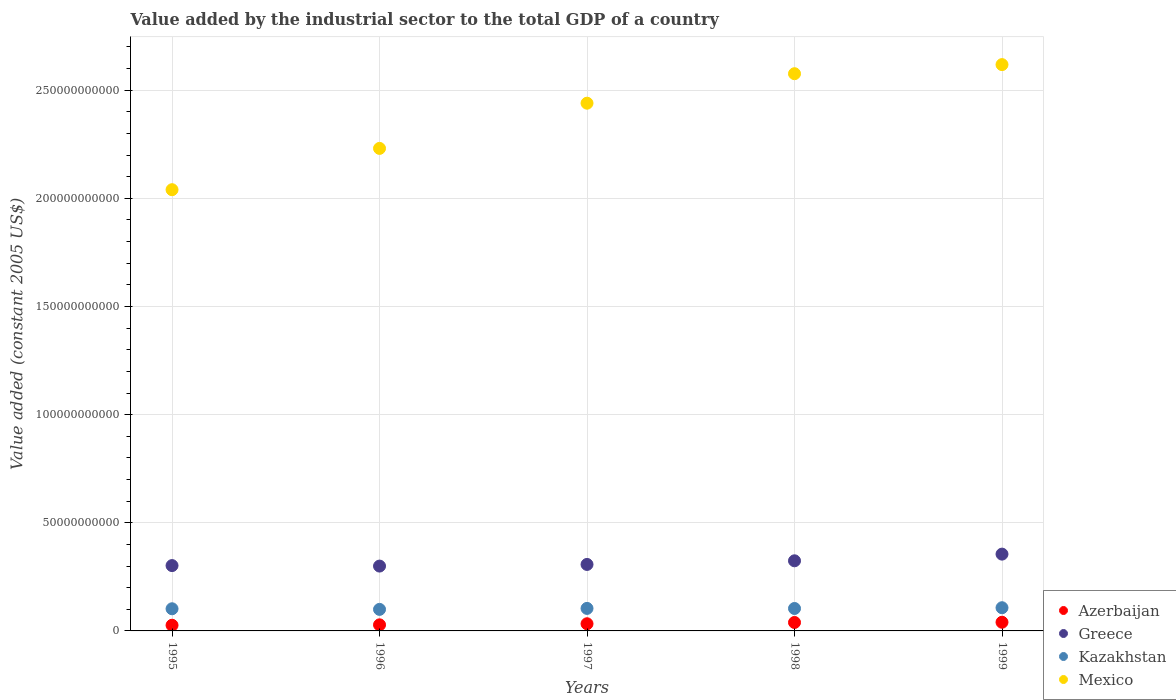How many different coloured dotlines are there?
Provide a succinct answer. 4. What is the value added by the industrial sector in Kazakhstan in 1999?
Your answer should be compact. 1.07e+1. Across all years, what is the maximum value added by the industrial sector in Mexico?
Give a very brief answer. 2.62e+11. Across all years, what is the minimum value added by the industrial sector in Kazakhstan?
Keep it short and to the point. 9.96e+09. In which year was the value added by the industrial sector in Mexico minimum?
Your answer should be compact. 1995. What is the total value added by the industrial sector in Mexico in the graph?
Your answer should be compact. 1.19e+12. What is the difference between the value added by the industrial sector in Greece in 1995 and that in 1999?
Provide a succinct answer. -5.30e+09. What is the difference between the value added by the industrial sector in Kazakhstan in 1999 and the value added by the industrial sector in Mexico in 1996?
Offer a very short reply. -2.12e+11. What is the average value added by the industrial sector in Mexico per year?
Ensure brevity in your answer.  2.38e+11. In the year 1995, what is the difference between the value added by the industrial sector in Kazakhstan and value added by the industrial sector in Azerbaijan?
Provide a succinct answer. 7.62e+09. In how many years, is the value added by the industrial sector in Azerbaijan greater than 80000000000 US$?
Give a very brief answer. 0. What is the ratio of the value added by the industrial sector in Azerbaijan in 1998 to that in 1999?
Your response must be concise. 0.97. What is the difference between the highest and the second highest value added by the industrial sector in Mexico?
Make the answer very short. 4.21e+09. What is the difference between the highest and the lowest value added by the industrial sector in Kazakhstan?
Your answer should be very brief. 7.63e+08. Is the sum of the value added by the industrial sector in Mexico in 1997 and 1999 greater than the maximum value added by the industrial sector in Kazakhstan across all years?
Offer a very short reply. Yes. Is it the case that in every year, the sum of the value added by the industrial sector in Kazakhstan and value added by the industrial sector in Azerbaijan  is greater than the sum of value added by the industrial sector in Mexico and value added by the industrial sector in Greece?
Your response must be concise. Yes. Is it the case that in every year, the sum of the value added by the industrial sector in Greece and value added by the industrial sector in Mexico  is greater than the value added by the industrial sector in Azerbaijan?
Keep it short and to the point. Yes. How many years are there in the graph?
Your answer should be very brief. 5. What is the difference between two consecutive major ticks on the Y-axis?
Offer a terse response. 5.00e+1. Does the graph contain grids?
Give a very brief answer. Yes. Where does the legend appear in the graph?
Offer a very short reply. Bottom right. How are the legend labels stacked?
Offer a terse response. Vertical. What is the title of the graph?
Provide a succinct answer. Value added by the industrial sector to the total GDP of a country. What is the label or title of the X-axis?
Your answer should be compact. Years. What is the label or title of the Y-axis?
Your answer should be very brief. Value added (constant 2005 US$). What is the Value added (constant 2005 US$) in Azerbaijan in 1995?
Ensure brevity in your answer.  2.62e+09. What is the Value added (constant 2005 US$) in Greece in 1995?
Your response must be concise. 3.02e+1. What is the Value added (constant 2005 US$) of Kazakhstan in 1995?
Your answer should be compact. 1.02e+1. What is the Value added (constant 2005 US$) of Mexico in 1995?
Give a very brief answer. 2.04e+11. What is the Value added (constant 2005 US$) of Azerbaijan in 1996?
Offer a terse response. 2.81e+09. What is the Value added (constant 2005 US$) of Greece in 1996?
Your response must be concise. 3.00e+1. What is the Value added (constant 2005 US$) of Kazakhstan in 1996?
Make the answer very short. 9.96e+09. What is the Value added (constant 2005 US$) in Mexico in 1996?
Provide a short and direct response. 2.23e+11. What is the Value added (constant 2005 US$) in Azerbaijan in 1997?
Provide a succinct answer. 3.31e+09. What is the Value added (constant 2005 US$) of Greece in 1997?
Give a very brief answer. 3.07e+1. What is the Value added (constant 2005 US$) in Kazakhstan in 1997?
Your answer should be very brief. 1.04e+1. What is the Value added (constant 2005 US$) in Mexico in 1997?
Your response must be concise. 2.44e+11. What is the Value added (constant 2005 US$) of Azerbaijan in 1998?
Your answer should be compact. 3.91e+09. What is the Value added (constant 2005 US$) in Greece in 1998?
Your answer should be compact. 3.24e+1. What is the Value added (constant 2005 US$) of Kazakhstan in 1998?
Provide a short and direct response. 1.04e+1. What is the Value added (constant 2005 US$) of Mexico in 1998?
Provide a short and direct response. 2.58e+11. What is the Value added (constant 2005 US$) of Azerbaijan in 1999?
Give a very brief answer. 4.01e+09. What is the Value added (constant 2005 US$) of Greece in 1999?
Give a very brief answer. 3.55e+1. What is the Value added (constant 2005 US$) of Kazakhstan in 1999?
Make the answer very short. 1.07e+1. What is the Value added (constant 2005 US$) in Mexico in 1999?
Provide a short and direct response. 2.62e+11. Across all years, what is the maximum Value added (constant 2005 US$) in Azerbaijan?
Offer a very short reply. 4.01e+09. Across all years, what is the maximum Value added (constant 2005 US$) of Greece?
Make the answer very short. 3.55e+1. Across all years, what is the maximum Value added (constant 2005 US$) in Kazakhstan?
Your answer should be compact. 1.07e+1. Across all years, what is the maximum Value added (constant 2005 US$) of Mexico?
Your response must be concise. 2.62e+11. Across all years, what is the minimum Value added (constant 2005 US$) of Azerbaijan?
Offer a terse response. 2.62e+09. Across all years, what is the minimum Value added (constant 2005 US$) of Greece?
Your answer should be very brief. 3.00e+1. Across all years, what is the minimum Value added (constant 2005 US$) of Kazakhstan?
Provide a succinct answer. 9.96e+09. Across all years, what is the minimum Value added (constant 2005 US$) of Mexico?
Offer a terse response. 2.04e+11. What is the total Value added (constant 2005 US$) in Azerbaijan in the graph?
Give a very brief answer. 1.67e+1. What is the total Value added (constant 2005 US$) of Greece in the graph?
Give a very brief answer. 1.59e+11. What is the total Value added (constant 2005 US$) in Kazakhstan in the graph?
Your answer should be compact. 5.17e+1. What is the total Value added (constant 2005 US$) of Mexico in the graph?
Your response must be concise. 1.19e+12. What is the difference between the Value added (constant 2005 US$) of Azerbaijan in 1995 and that in 1996?
Keep it short and to the point. -1.91e+08. What is the difference between the Value added (constant 2005 US$) of Greece in 1995 and that in 1996?
Your answer should be very brief. 2.27e+08. What is the difference between the Value added (constant 2005 US$) in Kazakhstan in 1995 and that in 1996?
Offer a terse response. 2.82e+08. What is the difference between the Value added (constant 2005 US$) of Mexico in 1995 and that in 1996?
Ensure brevity in your answer.  -1.91e+1. What is the difference between the Value added (constant 2005 US$) of Azerbaijan in 1995 and that in 1997?
Provide a succinct answer. -6.90e+08. What is the difference between the Value added (constant 2005 US$) of Greece in 1995 and that in 1997?
Give a very brief answer. -5.31e+08. What is the difference between the Value added (constant 2005 US$) in Kazakhstan in 1995 and that in 1997?
Your response must be concise. -1.69e+08. What is the difference between the Value added (constant 2005 US$) of Mexico in 1995 and that in 1997?
Your answer should be very brief. -4.00e+1. What is the difference between the Value added (constant 2005 US$) of Azerbaijan in 1995 and that in 1998?
Offer a very short reply. -1.28e+09. What is the difference between the Value added (constant 2005 US$) in Greece in 1995 and that in 1998?
Provide a succinct answer. -2.22e+09. What is the difference between the Value added (constant 2005 US$) of Kazakhstan in 1995 and that in 1998?
Provide a short and direct response. -1.28e+08. What is the difference between the Value added (constant 2005 US$) of Mexico in 1995 and that in 1998?
Provide a succinct answer. -5.36e+1. What is the difference between the Value added (constant 2005 US$) of Azerbaijan in 1995 and that in 1999?
Your answer should be compact. -1.39e+09. What is the difference between the Value added (constant 2005 US$) of Greece in 1995 and that in 1999?
Your response must be concise. -5.30e+09. What is the difference between the Value added (constant 2005 US$) of Kazakhstan in 1995 and that in 1999?
Offer a terse response. -4.80e+08. What is the difference between the Value added (constant 2005 US$) of Mexico in 1995 and that in 1999?
Provide a short and direct response. -5.78e+1. What is the difference between the Value added (constant 2005 US$) in Azerbaijan in 1996 and that in 1997?
Provide a short and direct response. -4.99e+08. What is the difference between the Value added (constant 2005 US$) in Greece in 1996 and that in 1997?
Ensure brevity in your answer.  -7.58e+08. What is the difference between the Value added (constant 2005 US$) in Kazakhstan in 1996 and that in 1997?
Ensure brevity in your answer.  -4.52e+08. What is the difference between the Value added (constant 2005 US$) in Mexico in 1996 and that in 1997?
Keep it short and to the point. -2.09e+1. What is the difference between the Value added (constant 2005 US$) of Azerbaijan in 1996 and that in 1998?
Make the answer very short. -1.09e+09. What is the difference between the Value added (constant 2005 US$) of Greece in 1996 and that in 1998?
Offer a terse response. -2.44e+09. What is the difference between the Value added (constant 2005 US$) in Kazakhstan in 1996 and that in 1998?
Provide a succinct answer. -4.10e+08. What is the difference between the Value added (constant 2005 US$) in Mexico in 1996 and that in 1998?
Provide a succinct answer. -3.45e+1. What is the difference between the Value added (constant 2005 US$) of Azerbaijan in 1996 and that in 1999?
Ensure brevity in your answer.  -1.19e+09. What is the difference between the Value added (constant 2005 US$) in Greece in 1996 and that in 1999?
Your response must be concise. -5.53e+09. What is the difference between the Value added (constant 2005 US$) of Kazakhstan in 1996 and that in 1999?
Offer a terse response. -7.63e+08. What is the difference between the Value added (constant 2005 US$) of Mexico in 1996 and that in 1999?
Give a very brief answer. -3.87e+1. What is the difference between the Value added (constant 2005 US$) of Azerbaijan in 1997 and that in 1998?
Keep it short and to the point. -5.93e+08. What is the difference between the Value added (constant 2005 US$) in Greece in 1997 and that in 1998?
Ensure brevity in your answer.  -1.68e+09. What is the difference between the Value added (constant 2005 US$) in Kazakhstan in 1997 and that in 1998?
Give a very brief answer. 4.17e+07. What is the difference between the Value added (constant 2005 US$) in Mexico in 1997 and that in 1998?
Offer a very short reply. -1.36e+1. What is the difference between the Value added (constant 2005 US$) in Azerbaijan in 1997 and that in 1999?
Provide a succinct answer. -6.96e+08. What is the difference between the Value added (constant 2005 US$) of Greece in 1997 and that in 1999?
Give a very brief answer. -4.77e+09. What is the difference between the Value added (constant 2005 US$) of Kazakhstan in 1997 and that in 1999?
Your answer should be very brief. -3.11e+08. What is the difference between the Value added (constant 2005 US$) of Mexico in 1997 and that in 1999?
Your answer should be compact. -1.78e+1. What is the difference between the Value added (constant 2005 US$) of Azerbaijan in 1998 and that in 1999?
Make the answer very short. -1.03e+08. What is the difference between the Value added (constant 2005 US$) in Greece in 1998 and that in 1999?
Keep it short and to the point. -3.09e+09. What is the difference between the Value added (constant 2005 US$) of Kazakhstan in 1998 and that in 1999?
Your answer should be very brief. -3.53e+08. What is the difference between the Value added (constant 2005 US$) of Mexico in 1998 and that in 1999?
Give a very brief answer. -4.21e+09. What is the difference between the Value added (constant 2005 US$) in Azerbaijan in 1995 and the Value added (constant 2005 US$) in Greece in 1996?
Keep it short and to the point. -2.74e+1. What is the difference between the Value added (constant 2005 US$) of Azerbaijan in 1995 and the Value added (constant 2005 US$) of Kazakhstan in 1996?
Offer a terse response. -7.34e+09. What is the difference between the Value added (constant 2005 US$) of Azerbaijan in 1995 and the Value added (constant 2005 US$) of Mexico in 1996?
Offer a very short reply. -2.20e+11. What is the difference between the Value added (constant 2005 US$) of Greece in 1995 and the Value added (constant 2005 US$) of Kazakhstan in 1996?
Keep it short and to the point. 2.02e+1. What is the difference between the Value added (constant 2005 US$) of Greece in 1995 and the Value added (constant 2005 US$) of Mexico in 1996?
Offer a terse response. -1.93e+11. What is the difference between the Value added (constant 2005 US$) in Kazakhstan in 1995 and the Value added (constant 2005 US$) in Mexico in 1996?
Keep it short and to the point. -2.13e+11. What is the difference between the Value added (constant 2005 US$) of Azerbaijan in 1995 and the Value added (constant 2005 US$) of Greece in 1997?
Your answer should be very brief. -2.81e+1. What is the difference between the Value added (constant 2005 US$) of Azerbaijan in 1995 and the Value added (constant 2005 US$) of Kazakhstan in 1997?
Make the answer very short. -7.79e+09. What is the difference between the Value added (constant 2005 US$) in Azerbaijan in 1995 and the Value added (constant 2005 US$) in Mexico in 1997?
Your answer should be compact. -2.41e+11. What is the difference between the Value added (constant 2005 US$) of Greece in 1995 and the Value added (constant 2005 US$) of Kazakhstan in 1997?
Your answer should be compact. 1.98e+1. What is the difference between the Value added (constant 2005 US$) in Greece in 1995 and the Value added (constant 2005 US$) in Mexico in 1997?
Keep it short and to the point. -2.14e+11. What is the difference between the Value added (constant 2005 US$) of Kazakhstan in 1995 and the Value added (constant 2005 US$) of Mexico in 1997?
Your answer should be very brief. -2.34e+11. What is the difference between the Value added (constant 2005 US$) in Azerbaijan in 1995 and the Value added (constant 2005 US$) in Greece in 1998?
Your response must be concise. -2.98e+1. What is the difference between the Value added (constant 2005 US$) of Azerbaijan in 1995 and the Value added (constant 2005 US$) of Kazakhstan in 1998?
Provide a succinct answer. -7.75e+09. What is the difference between the Value added (constant 2005 US$) in Azerbaijan in 1995 and the Value added (constant 2005 US$) in Mexico in 1998?
Offer a very short reply. -2.55e+11. What is the difference between the Value added (constant 2005 US$) of Greece in 1995 and the Value added (constant 2005 US$) of Kazakhstan in 1998?
Ensure brevity in your answer.  1.98e+1. What is the difference between the Value added (constant 2005 US$) in Greece in 1995 and the Value added (constant 2005 US$) in Mexico in 1998?
Provide a succinct answer. -2.27e+11. What is the difference between the Value added (constant 2005 US$) in Kazakhstan in 1995 and the Value added (constant 2005 US$) in Mexico in 1998?
Your answer should be compact. -2.47e+11. What is the difference between the Value added (constant 2005 US$) of Azerbaijan in 1995 and the Value added (constant 2005 US$) of Greece in 1999?
Offer a terse response. -3.29e+1. What is the difference between the Value added (constant 2005 US$) of Azerbaijan in 1995 and the Value added (constant 2005 US$) of Kazakhstan in 1999?
Ensure brevity in your answer.  -8.10e+09. What is the difference between the Value added (constant 2005 US$) in Azerbaijan in 1995 and the Value added (constant 2005 US$) in Mexico in 1999?
Make the answer very short. -2.59e+11. What is the difference between the Value added (constant 2005 US$) in Greece in 1995 and the Value added (constant 2005 US$) in Kazakhstan in 1999?
Your response must be concise. 1.95e+1. What is the difference between the Value added (constant 2005 US$) of Greece in 1995 and the Value added (constant 2005 US$) of Mexico in 1999?
Your response must be concise. -2.32e+11. What is the difference between the Value added (constant 2005 US$) of Kazakhstan in 1995 and the Value added (constant 2005 US$) of Mexico in 1999?
Provide a succinct answer. -2.52e+11. What is the difference between the Value added (constant 2005 US$) in Azerbaijan in 1996 and the Value added (constant 2005 US$) in Greece in 1997?
Your answer should be very brief. -2.79e+1. What is the difference between the Value added (constant 2005 US$) of Azerbaijan in 1996 and the Value added (constant 2005 US$) of Kazakhstan in 1997?
Provide a short and direct response. -7.60e+09. What is the difference between the Value added (constant 2005 US$) in Azerbaijan in 1996 and the Value added (constant 2005 US$) in Mexico in 1997?
Your answer should be very brief. -2.41e+11. What is the difference between the Value added (constant 2005 US$) in Greece in 1996 and the Value added (constant 2005 US$) in Kazakhstan in 1997?
Provide a short and direct response. 1.96e+1. What is the difference between the Value added (constant 2005 US$) of Greece in 1996 and the Value added (constant 2005 US$) of Mexico in 1997?
Offer a very short reply. -2.14e+11. What is the difference between the Value added (constant 2005 US$) in Kazakhstan in 1996 and the Value added (constant 2005 US$) in Mexico in 1997?
Make the answer very short. -2.34e+11. What is the difference between the Value added (constant 2005 US$) in Azerbaijan in 1996 and the Value added (constant 2005 US$) in Greece in 1998?
Your answer should be compact. -2.96e+1. What is the difference between the Value added (constant 2005 US$) in Azerbaijan in 1996 and the Value added (constant 2005 US$) in Kazakhstan in 1998?
Your answer should be compact. -7.56e+09. What is the difference between the Value added (constant 2005 US$) of Azerbaijan in 1996 and the Value added (constant 2005 US$) of Mexico in 1998?
Keep it short and to the point. -2.55e+11. What is the difference between the Value added (constant 2005 US$) of Greece in 1996 and the Value added (constant 2005 US$) of Kazakhstan in 1998?
Your answer should be very brief. 1.96e+1. What is the difference between the Value added (constant 2005 US$) in Greece in 1996 and the Value added (constant 2005 US$) in Mexico in 1998?
Provide a succinct answer. -2.28e+11. What is the difference between the Value added (constant 2005 US$) of Kazakhstan in 1996 and the Value added (constant 2005 US$) of Mexico in 1998?
Make the answer very short. -2.48e+11. What is the difference between the Value added (constant 2005 US$) in Azerbaijan in 1996 and the Value added (constant 2005 US$) in Greece in 1999?
Provide a succinct answer. -3.27e+1. What is the difference between the Value added (constant 2005 US$) of Azerbaijan in 1996 and the Value added (constant 2005 US$) of Kazakhstan in 1999?
Keep it short and to the point. -7.91e+09. What is the difference between the Value added (constant 2005 US$) of Azerbaijan in 1996 and the Value added (constant 2005 US$) of Mexico in 1999?
Give a very brief answer. -2.59e+11. What is the difference between the Value added (constant 2005 US$) in Greece in 1996 and the Value added (constant 2005 US$) in Kazakhstan in 1999?
Give a very brief answer. 1.93e+1. What is the difference between the Value added (constant 2005 US$) of Greece in 1996 and the Value added (constant 2005 US$) of Mexico in 1999?
Ensure brevity in your answer.  -2.32e+11. What is the difference between the Value added (constant 2005 US$) of Kazakhstan in 1996 and the Value added (constant 2005 US$) of Mexico in 1999?
Your response must be concise. -2.52e+11. What is the difference between the Value added (constant 2005 US$) of Azerbaijan in 1997 and the Value added (constant 2005 US$) of Greece in 1998?
Provide a short and direct response. -2.91e+1. What is the difference between the Value added (constant 2005 US$) of Azerbaijan in 1997 and the Value added (constant 2005 US$) of Kazakhstan in 1998?
Offer a terse response. -7.06e+09. What is the difference between the Value added (constant 2005 US$) of Azerbaijan in 1997 and the Value added (constant 2005 US$) of Mexico in 1998?
Your response must be concise. -2.54e+11. What is the difference between the Value added (constant 2005 US$) of Greece in 1997 and the Value added (constant 2005 US$) of Kazakhstan in 1998?
Offer a very short reply. 2.04e+1. What is the difference between the Value added (constant 2005 US$) in Greece in 1997 and the Value added (constant 2005 US$) in Mexico in 1998?
Your answer should be compact. -2.27e+11. What is the difference between the Value added (constant 2005 US$) in Kazakhstan in 1997 and the Value added (constant 2005 US$) in Mexico in 1998?
Make the answer very short. -2.47e+11. What is the difference between the Value added (constant 2005 US$) of Azerbaijan in 1997 and the Value added (constant 2005 US$) of Greece in 1999?
Your response must be concise. -3.22e+1. What is the difference between the Value added (constant 2005 US$) in Azerbaijan in 1997 and the Value added (constant 2005 US$) in Kazakhstan in 1999?
Ensure brevity in your answer.  -7.41e+09. What is the difference between the Value added (constant 2005 US$) of Azerbaijan in 1997 and the Value added (constant 2005 US$) of Mexico in 1999?
Your answer should be compact. -2.59e+11. What is the difference between the Value added (constant 2005 US$) of Greece in 1997 and the Value added (constant 2005 US$) of Kazakhstan in 1999?
Keep it short and to the point. 2.00e+1. What is the difference between the Value added (constant 2005 US$) of Greece in 1997 and the Value added (constant 2005 US$) of Mexico in 1999?
Make the answer very short. -2.31e+11. What is the difference between the Value added (constant 2005 US$) in Kazakhstan in 1997 and the Value added (constant 2005 US$) in Mexico in 1999?
Provide a succinct answer. -2.51e+11. What is the difference between the Value added (constant 2005 US$) of Azerbaijan in 1998 and the Value added (constant 2005 US$) of Greece in 1999?
Provide a short and direct response. -3.16e+1. What is the difference between the Value added (constant 2005 US$) of Azerbaijan in 1998 and the Value added (constant 2005 US$) of Kazakhstan in 1999?
Ensure brevity in your answer.  -6.82e+09. What is the difference between the Value added (constant 2005 US$) in Azerbaijan in 1998 and the Value added (constant 2005 US$) in Mexico in 1999?
Make the answer very short. -2.58e+11. What is the difference between the Value added (constant 2005 US$) of Greece in 1998 and the Value added (constant 2005 US$) of Kazakhstan in 1999?
Give a very brief answer. 2.17e+1. What is the difference between the Value added (constant 2005 US$) in Greece in 1998 and the Value added (constant 2005 US$) in Mexico in 1999?
Your answer should be very brief. -2.29e+11. What is the difference between the Value added (constant 2005 US$) of Kazakhstan in 1998 and the Value added (constant 2005 US$) of Mexico in 1999?
Your answer should be very brief. -2.51e+11. What is the average Value added (constant 2005 US$) of Azerbaijan per year?
Keep it short and to the point. 3.33e+09. What is the average Value added (constant 2005 US$) of Greece per year?
Your answer should be compact. 3.18e+1. What is the average Value added (constant 2005 US$) in Kazakhstan per year?
Make the answer very short. 1.03e+1. What is the average Value added (constant 2005 US$) of Mexico per year?
Your answer should be compact. 2.38e+11. In the year 1995, what is the difference between the Value added (constant 2005 US$) in Azerbaijan and Value added (constant 2005 US$) in Greece?
Provide a short and direct response. -2.76e+1. In the year 1995, what is the difference between the Value added (constant 2005 US$) of Azerbaijan and Value added (constant 2005 US$) of Kazakhstan?
Provide a succinct answer. -7.62e+09. In the year 1995, what is the difference between the Value added (constant 2005 US$) of Azerbaijan and Value added (constant 2005 US$) of Mexico?
Provide a succinct answer. -2.01e+11. In the year 1995, what is the difference between the Value added (constant 2005 US$) in Greece and Value added (constant 2005 US$) in Kazakhstan?
Provide a succinct answer. 2.00e+1. In the year 1995, what is the difference between the Value added (constant 2005 US$) of Greece and Value added (constant 2005 US$) of Mexico?
Your answer should be compact. -1.74e+11. In the year 1995, what is the difference between the Value added (constant 2005 US$) in Kazakhstan and Value added (constant 2005 US$) in Mexico?
Make the answer very short. -1.94e+11. In the year 1996, what is the difference between the Value added (constant 2005 US$) in Azerbaijan and Value added (constant 2005 US$) in Greece?
Provide a short and direct response. -2.72e+1. In the year 1996, what is the difference between the Value added (constant 2005 US$) in Azerbaijan and Value added (constant 2005 US$) in Kazakhstan?
Provide a succinct answer. -7.15e+09. In the year 1996, what is the difference between the Value added (constant 2005 US$) in Azerbaijan and Value added (constant 2005 US$) in Mexico?
Your answer should be very brief. -2.20e+11. In the year 1996, what is the difference between the Value added (constant 2005 US$) of Greece and Value added (constant 2005 US$) of Kazakhstan?
Offer a terse response. 2.00e+1. In the year 1996, what is the difference between the Value added (constant 2005 US$) in Greece and Value added (constant 2005 US$) in Mexico?
Give a very brief answer. -1.93e+11. In the year 1996, what is the difference between the Value added (constant 2005 US$) in Kazakhstan and Value added (constant 2005 US$) in Mexico?
Your response must be concise. -2.13e+11. In the year 1997, what is the difference between the Value added (constant 2005 US$) of Azerbaijan and Value added (constant 2005 US$) of Greece?
Give a very brief answer. -2.74e+1. In the year 1997, what is the difference between the Value added (constant 2005 US$) in Azerbaijan and Value added (constant 2005 US$) in Kazakhstan?
Offer a terse response. -7.10e+09. In the year 1997, what is the difference between the Value added (constant 2005 US$) of Azerbaijan and Value added (constant 2005 US$) of Mexico?
Your answer should be very brief. -2.41e+11. In the year 1997, what is the difference between the Value added (constant 2005 US$) in Greece and Value added (constant 2005 US$) in Kazakhstan?
Offer a terse response. 2.03e+1. In the year 1997, what is the difference between the Value added (constant 2005 US$) in Greece and Value added (constant 2005 US$) in Mexico?
Your answer should be very brief. -2.13e+11. In the year 1997, what is the difference between the Value added (constant 2005 US$) in Kazakhstan and Value added (constant 2005 US$) in Mexico?
Offer a terse response. -2.34e+11. In the year 1998, what is the difference between the Value added (constant 2005 US$) in Azerbaijan and Value added (constant 2005 US$) in Greece?
Ensure brevity in your answer.  -2.85e+1. In the year 1998, what is the difference between the Value added (constant 2005 US$) of Azerbaijan and Value added (constant 2005 US$) of Kazakhstan?
Keep it short and to the point. -6.47e+09. In the year 1998, what is the difference between the Value added (constant 2005 US$) in Azerbaijan and Value added (constant 2005 US$) in Mexico?
Provide a short and direct response. -2.54e+11. In the year 1998, what is the difference between the Value added (constant 2005 US$) of Greece and Value added (constant 2005 US$) of Kazakhstan?
Provide a succinct answer. 2.21e+1. In the year 1998, what is the difference between the Value added (constant 2005 US$) of Greece and Value added (constant 2005 US$) of Mexico?
Ensure brevity in your answer.  -2.25e+11. In the year 1998, what is the difference between the Value added (constant 2005 US$) in Kazakhstan and Value added (constant 2005 US$) in Mexico?
Ensure brevity in your answer.  -2.47e+11. In the year 1999, what is the difference between the Value added (constant 2005 US$) of Azerbaijan and Value added (constant 2005 US$) of Greece?
Provide a short and direct response. -3.15e+1. In the year 1999, what is the difference between the Value added (constant 2005 US$) in Azerbaijan and Value added (constant 2005 US$) in Kazakhstan?
Give a very brief answer. -6.72e+09. In the year 1999, what is the difference between the Value added (constant 2005 US$) in Azerbaijan and Value added (constant 2005 US$) in Mexico?
Your response must be concise. -2.58e+11. In the year 1999, what is the difference between the Value added (constant 2005 US$) in Greece and Value added (constant 2005 US$) in Kazakhstan?
Your answer should be very brief. 2.48e+1. In the year 1999, what is the difference between the Value added (constant 2005 US$) in Greece and Value added (constant 2005 US$) in Mexico?
Give a very brief answer. -2.26e+11. In the year 1999, what is the difference between the Value added (constant 2005 US$) in Kazakhstan and Value added (constant 2005 US$) in Mexico?
Make the answer very short. -2.51e+11. What is the ratio of the Value added (constant 2005 US$) of Azerbaijan in 1995 to that in 1996?
Make the answer very short. 0.93. What is the ratio of the Value added (constant 2005 US$) in Greece in 1995 to that in 1996?
Offer a terse response. 1.01. What is the ratio of the Value added (constant 2005 US$) of Kazakhstan in 1995 to that in 1996?
Your answer should be very brief. 1.03. What is the ratio of the Value added (constant 2005 US$) of Mexico in 1995 to that in 1996?
Keep it short and to the point. 0.91. What is the ratio of the Value added (constant 2005 US$) in Azerbaijan in 1995 to that in 1997?
Provide a succinct answer. 0.79. What is the ratio of the Value added (constant 2005 US$) of Greece in 1995 to that in 1997?
Offer a terse response. 0.98. What is the ratio of the Value added (constant 2005 US$) in Kazakhstan in 1995 to that in 1997?
Make the answer very short. 0.98. What is the ratio of the Value added (constant 2005 US$) in Mexico in 1995 to that in 1997?
Your answer should be compact. 0.84. What is the ratio of the Value added (constant 2005 US$) in Azerbaijan in 1995 to that in 1998?
Ensure brevity in your answer.  0.67. What is the ratio of the Value added (constant 2005 US$) in Greece in 1995 to that in 1998?
Your answer should be compact. 0.93. What is the ratio of the Value added (constant 2005 US$) of Kazakhstan in 1995 to that in 1998?
Your answer should be very brief. 0.99. What is the ratio of the Value added (constant 2005 US$) in Mexico in 1995 to that in 1998?
Make the answer very short. 0.79. What is the ratio of the Value added (constant 2005 US$) of Azerbaijan in 1995 to that in 1999?
Your answer should be compact. 0.65. What is the ratio of the Value added (constant 2005 US$) of Greece in 1995 to that in 1999?
Your answer should be very brief. 0.85. What is the ratio of the Value added (constant 2005 US$) of Kazakhstan in 1995 to that in 1999?
Your answer should be very brief. 0.96. What is the ratio of the Value added (constant 2005 US$) of Mexico in 1995 to that in 1999?
Make the answer very short. 0.78. What is the ratio of the Value added (constant 2005 US$) in Azerbaijan in 1996 to that in 1997?
Provide a succinct answer. 0.85. What is the ratio of the Value added (constant 2005 US$) of Greece in 1996 to that in 1997?
Offer a very short reply. 0.98. What is the ratio of the Value added (constant 2005 US$) in Kazakhstan in 1996 to that in 1997?
Your response must be concise. 0.96. What is the ratio of the Value added (constant 2005 US$) of Mexico in 1996 to that in 1997?
Your answer should be compact. 0.91. What is the ratio of the Value added (constant 2005 US$) in Azerbaijan in 1996 to that in 1998?
Give a very brief answer. 0.72. What is the ratio of the Value added (constant 2005 US$) in Greece in 1996 to that in 1998?
Your answer should be compact. 0.92. What is the ratio of the Value added (constant 2005 US$) in Kazakhstan in 1996 to that in 1998?
Your answer should be very brief. 0.96. What is the ratio of the Value added (constant 2005 US$) of Mexico in 1996 to that in 1998?
Provide a succinct answer. 0.87. What is the ratio of the Value added (constant 2005 US$) of Azerbaijan in 1996 to that in 1999?
Provide a short and direct response. 0.7. What is the ratio of the Value added (constant 2005 US$) in Greece in 1996 to that in 1999?
Provide a succinct answer. 0.84. What is the ratio of the Value added (constant 2005 US$) in Kazakhstan in 1996 to that in 1999?
Keep it short and to the point. 0.93. What is the ratio of the Value added (constant 2005 US$) of Mexico in 1996 to that in 1999?
Ensure brevity in your answer.  0.85. What is the ratio of the Value added (constant 2005 US$) of Azerbaijan in 1997 to that in 1998?
Ensure brevity in your answer.  0.85. What is the ratio of the Value added (constant 2005 US$) of Greece in 1997 to that in 1998?
Make the answer very short. 0.95. What is the ratio of the Value added (constant 2005 US$) of Mexico in 1997 to that in 1998?
Make the answer very short. 0.95. What is the ratio of the Value added (constant 2005 US$) in Azerbaijan in 1997 to that in 1999?
Make the answer very short. 0.83. What is the ratio of the Value added (constant 2005 US$) in Greece in 1997 to that in 1999?
Your response must be concise. 0.87. What is the ratio of the Value added (constant 2005 US$) in Mexico in 1997 to that in 1999?
Provide a succinct answer. 0.93. What is the ratio of the Value added (constant 2005 US$) of Azerbaijan in 1998 to that in 1999?
Ensure brevity in your answer.  0.97. What is the ratio of the Value added (constant 2005 US$) in Greece in 1998 to that in 1999?
Make the answer very short. 0.91. What is the ratio of the Value added (constant 2005 US$) of Kazakhstan in 1998 to that in 1999?
Your response must be concise. 0.97. What is the ratio of the Value added (constant 2005 US$) of Mexico in 1998 to that in 1999?
Ensure brevity in your answer.  0.98. What is the difference between the highest and the second highest Value added (constant 2005 US$) in Azerbaijan?
Your answer should be very brief. 1.03e+08. What is the difference between the highest and the second highest Value added (constant 2005 US$) in Greece?
Provide a succinct answer. 3.09e+09. What is the difference between the highest and the second highest Value added (constant 2005 US$) in Kazakhstan?
Make the answer very short. 3.11e+08. What is the difference between the highest and the second highest Value added (constant 2005 US$) of Mexico?
Give a very brief answer. 4.21e+09. What is the difference between the highest and the lowest Value added (constant 2005 US$) in Azerbaijan?
Your answer should be very brief. 1.39e+09. What is the difference between the highest and the lowest Value added (constant 2005 US$) of Greece?
Ensure brevity in your answer.  5.53e+09. What is the difference between the highest and the lowest Value added (constant 2005 US$) of Kazakhstan?
Provide a short and direct response. 7.63e+08. What is the difference between the highest and the lowest Value added (constant 2005 US$) in Mexico?
Offer a very short reply. 5.78e+1. 